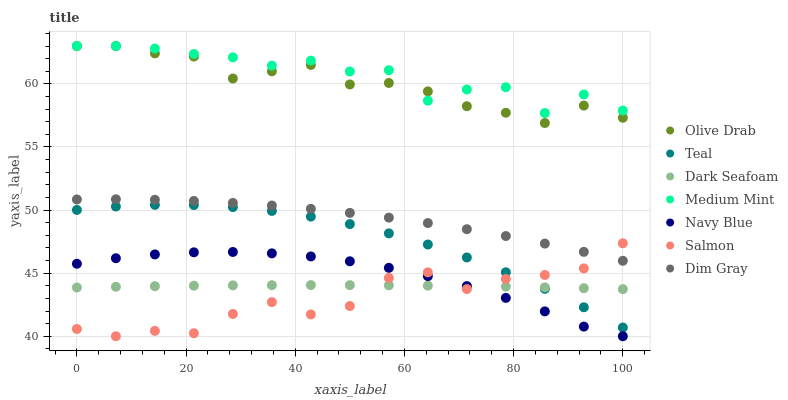Does Salmon have the minimum area under the curve?
Answer yes or no. Yes. Does Medium Mint have the maximum area under the curve?
Answer yes or no. Yes. Does Dim Gray have the minimum area under the curve?
Answer yes or no. No. Does Dim Gray have the maximum area under the curve?
Answer yes or no. No. Is Dark Seafoam the smoothest?
Answer yes or no. Yes. Is Medium Mint the roughest?
Answer yes or no. Yes. Is Dim Gray the smoothest?
Answer yes or no. No. Is Dim Gray the roughest?
Answer yes or no. No. Does Navy Blue have the lowest value?
Answer yes or no. Yes. Does Dim Gray have the lowest value?
Answer yes or no. No. Does Olive Drab have the highest value?
Answer yes or no. Yes. Does Dim Gray have the highest value?
Answer yes or no. No. Is Dim Gray less than Medium Mint?
Answer yes or no. Yes. Is Dim Gray greater than Dark Seafoam?
Answer yes or no. Yes. Does Olive Drab intersect Medium Mint?
Answer yes or no. Yes. Is Olive Drab less than Medium Mint?
Answer yes or no. No. Is Olive Drab greater than Medium Mint?
Answer yes or no. No. Does Dim Gray intersect Medium Mint?
Answer yes or no. No. 